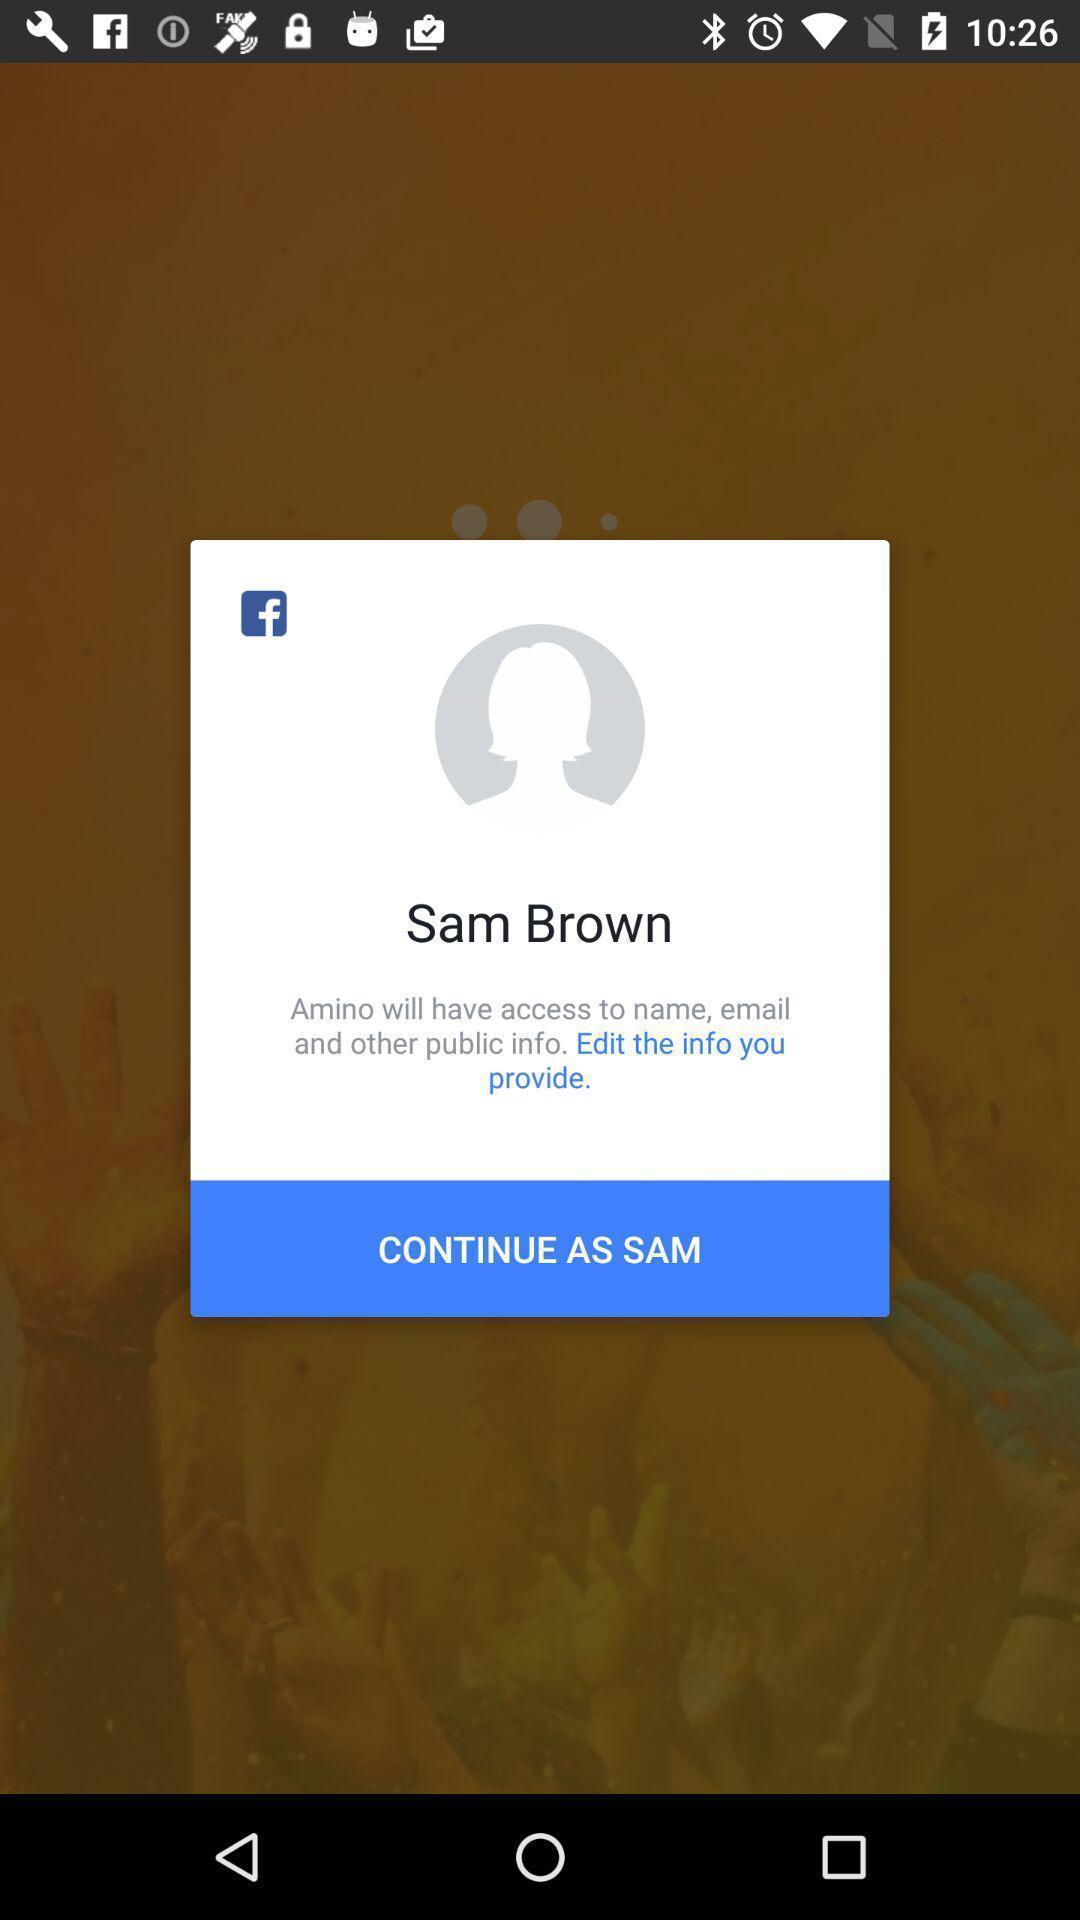Explain the elements present in this screenshot. Pop-up displaying to continue in app. 